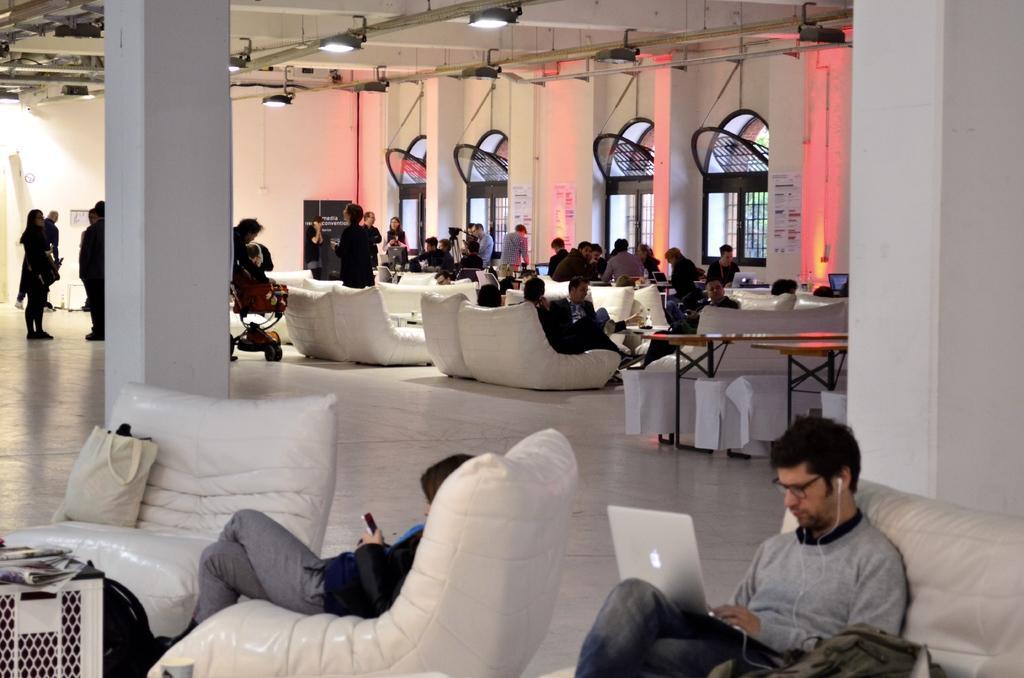Can you describe this image briefly? In the image in the center, we can see two persons are sitting and holding some objects. And we can see the bags, papers and a few other objects. In the background there is a wall, roof, windows, lights, tables, sofas, pillars, few people are sitting and few people are standing. 